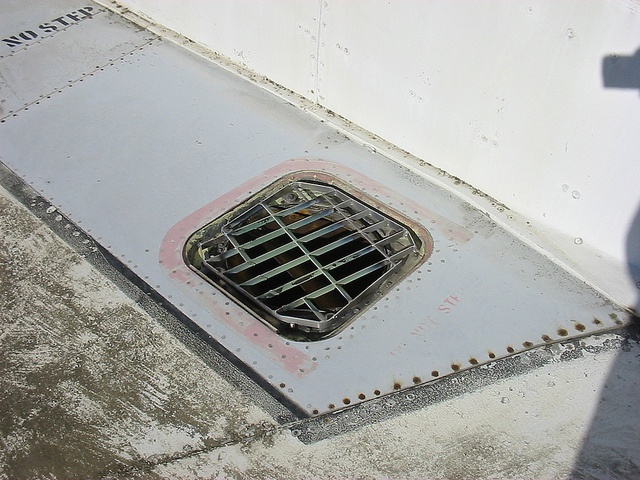Describe the objects in this image and their specific colors. I can see a airplane in darkgray, lightgray, gray, and black tones in this image. 